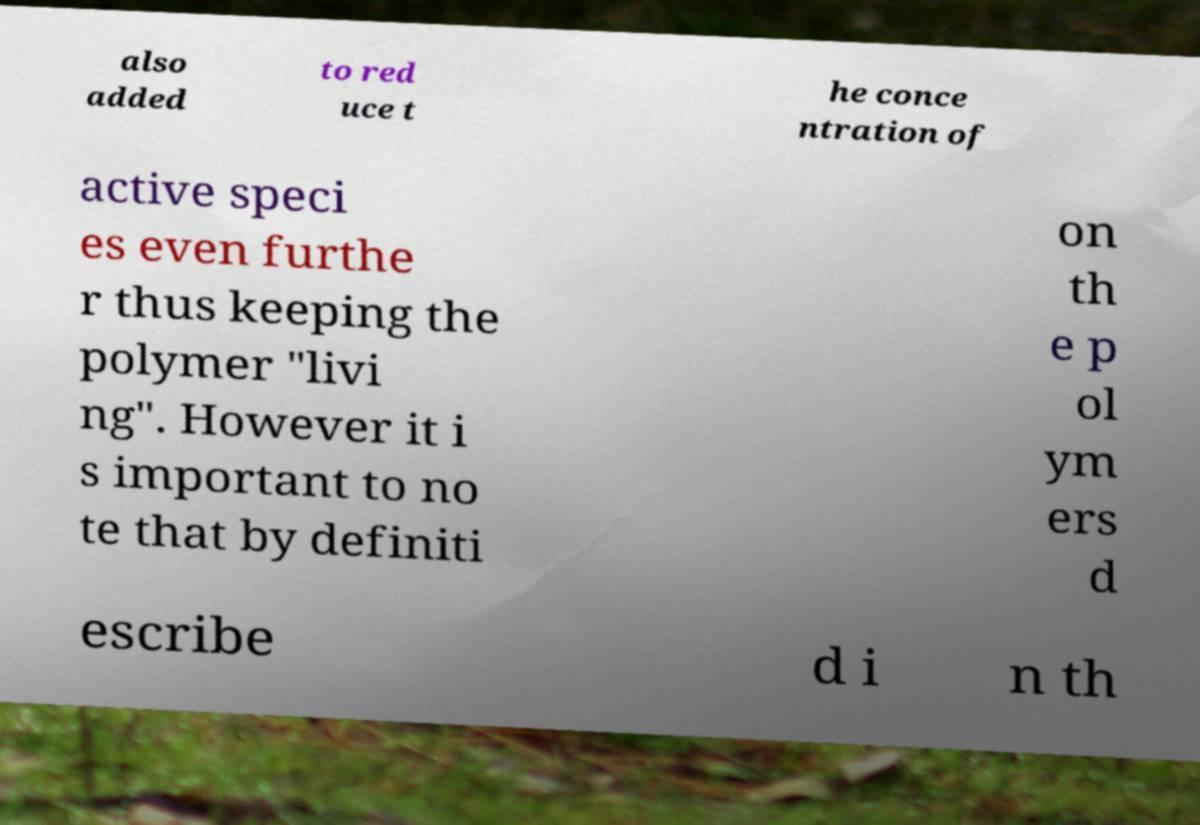For documentation purposes, I need the text within this image transcribed. Could you provide that? also added to red uce t he conce ntration of active speci es even furthe r thus keeping the polymer "livi ng". However it i s important to no te that by definiti on th e p ol ym ers d escribe d i n th 